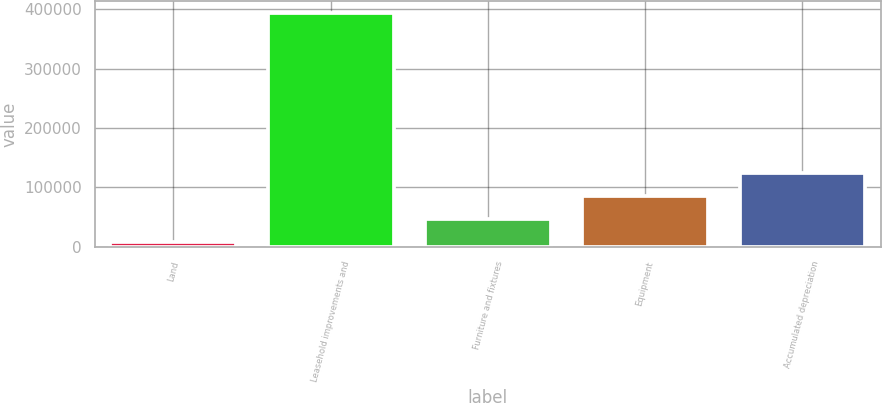Convert chart to OTSL. <chart><loc_0><loc_0><loc_500><loc_500><bar_chart><fcel>Land<fcel>Leasehold improvements and<fcel>Furniture and fixtures<fcel>Equipment<fcel>Accumulated depreciation<nl><fcel>8215<fcel>393980<fcel>46791.5<fcel>85368<fcel>123944<nl></chart> 